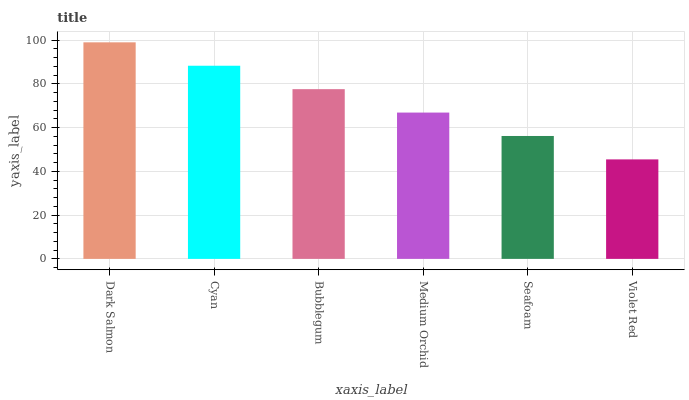Is Violet Red the minimum?
Answer yes or no. Yes. Is Dark Salmon the maximum?
Answer yes or no. Yes. Is Cyan the minimum?
Answer yes or no. No. Is Cyan the maximum?
Answer yes or no. No. Is Dark Salmon greater than Cyan?
Answer yes or no. Yes. Is Cyan less than Dark Salmon?
Answer yes or no. Yes. Is Cyan greater than Dark Salmon?
Answer yes or no. No. Is Dark Salmon less than Cyan?
Answer yes or no. No. Is Bubblegum the high median?
Answer yes or no. Yes. Is Medium Orchid the low median?
Answer yes or no. Yes. Is Dark Salmon the high median?
Answer yes or no. No. Is Cyan the low median?
Answer yes or no. No. 